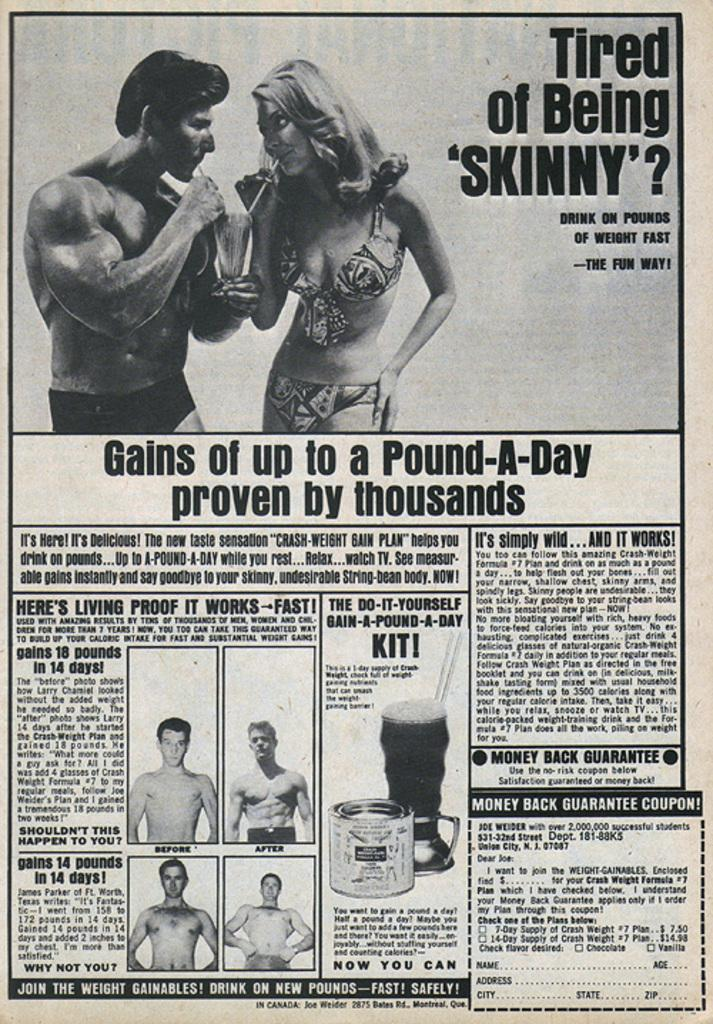What is the main object visible in the image? There is a newspaper in the image. What type of content can be seen on the newspaper? There are person images and text visible on the newspaper. What type of smell can be detected from the newspaper in the image? There is no indication of a smell in the image, as it is a visual representation. What type of flag is visible on the newspaper in the image? There is no flag present on the newspaper in the image. 